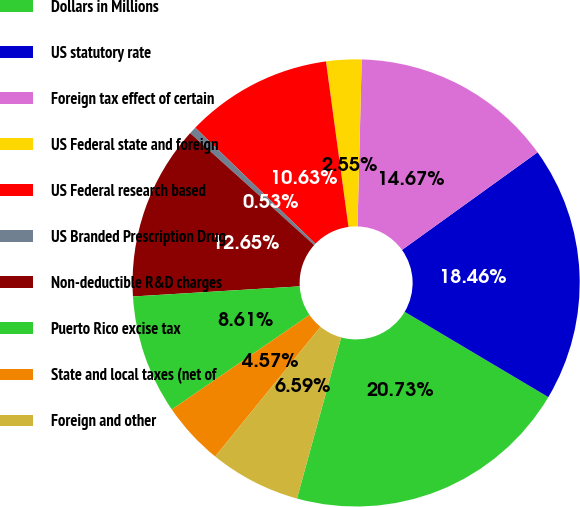Convert chart. <chart><loc_0><loc_0><loc_500><loc_500><pie_chart><fcel>Dollars in Millions<fcel>US statutory rate<fcel>Foreign tax effect of certain<fcel>US Federal state and foreign<fcel>US Federal research based<fcel>US Branded Prescription Drug<fcel>Non-deductible R&D charges<fcel>Puerto Rico excise tax<fcel>State and local taxes (net of<fcel>Foreign and other<nl><fcel>20.73%<fcel>18.46%<fcel>14.67%<fcel>2.55%<fcel>10.63%<fcel>0.53%<fcel>12.65%<fcel>8.61%<fcel>4.57%<fcel>6.59%<nl></chart> 